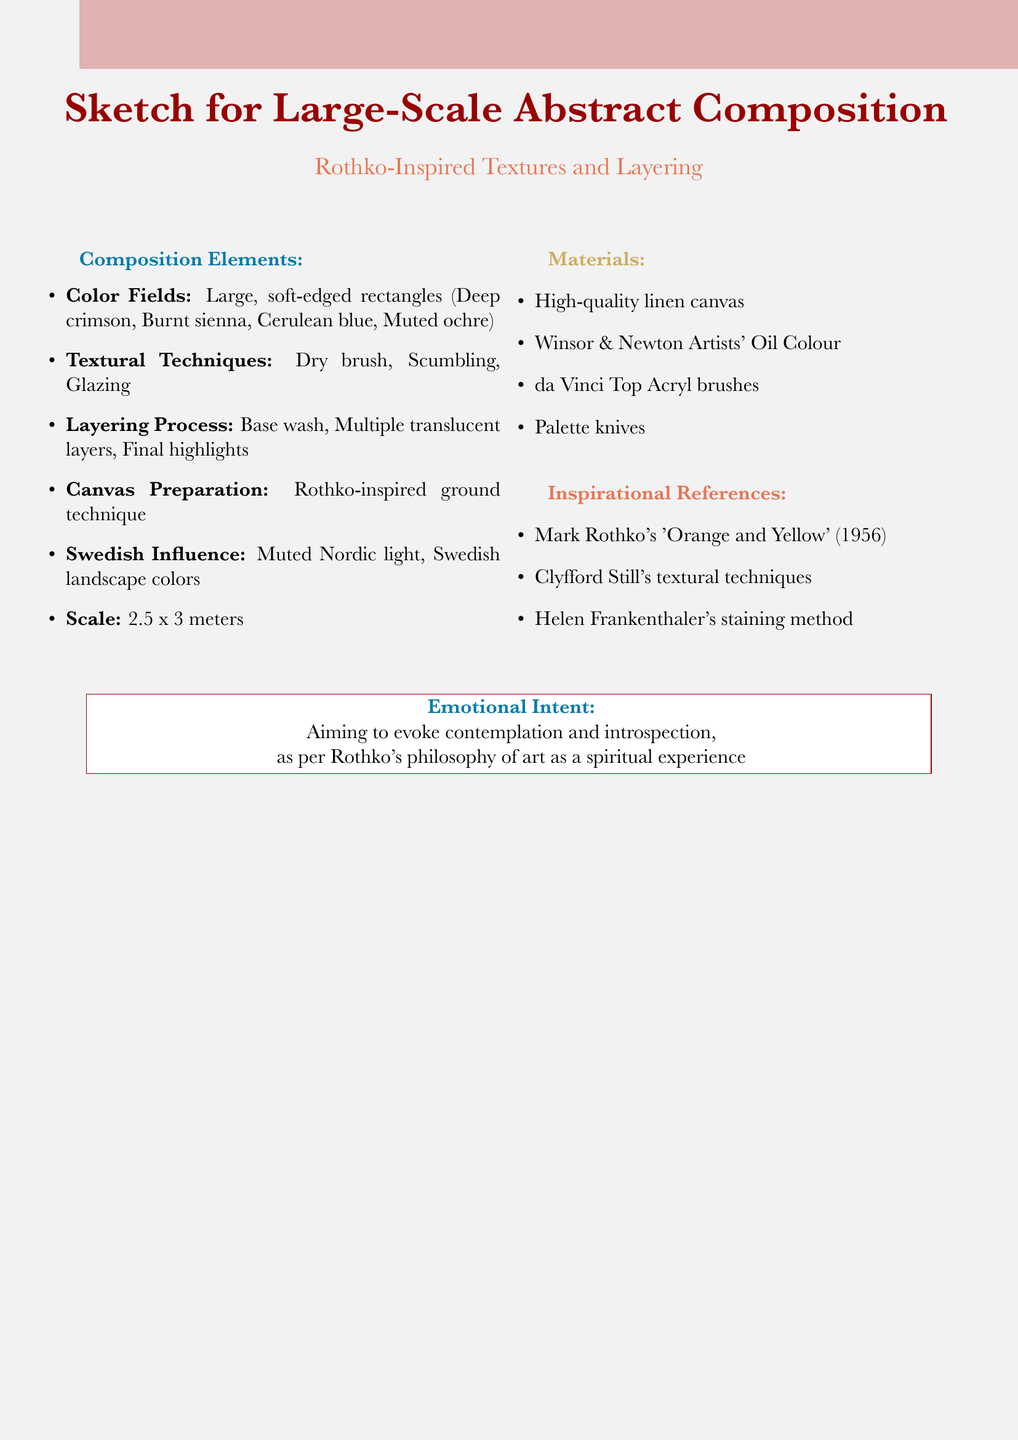What are the primary colors used in the composition? The primary colors listed in the document are Deep crimson, Burnt sienna, Cerulean blue, and Muted ochre.
Answer: Deep crimson, Burnt sienna, Cerulean blue, Muted ochre What is the scale of the canvas? The document specifies the size of the canvas, which is approximately 2.5 x 3 meters.
Answer: 2.5 x 3 meters Which emotional intent is mentioned? The intent described in the document is to evoke contemplation and introspection, following Rothko's philosophy.
Answer: Contemplation and introspection What technique is used for the canvas preparation? The method noted is the Rothko-inspired ground technique using rabbit skin glue and titanium white.
Answer: Rothko-inspired ground technique How many main textural techniques are identified? The document lists three textural techniques: dry brush, scumbling, and glazing.
Answer: Three What Swedish influence is incorporated in the composition? The document mentions the incorporation of muted Nordic light qualities and references to Swedish landscape colors.
Answer: Muted Nordic light qualities, Swedish landscape colors Which artist's work from 1956 is referenced? The document references Mark Rothko's work entitled 'Orange and Yellow' from the year 1956.
Answer: 'Orange and Yellow' What is the final step in the layering process? The final layer consists of subtle highlights and shadows to add depth.
Answer: Subtle highlights and shadows for depth 